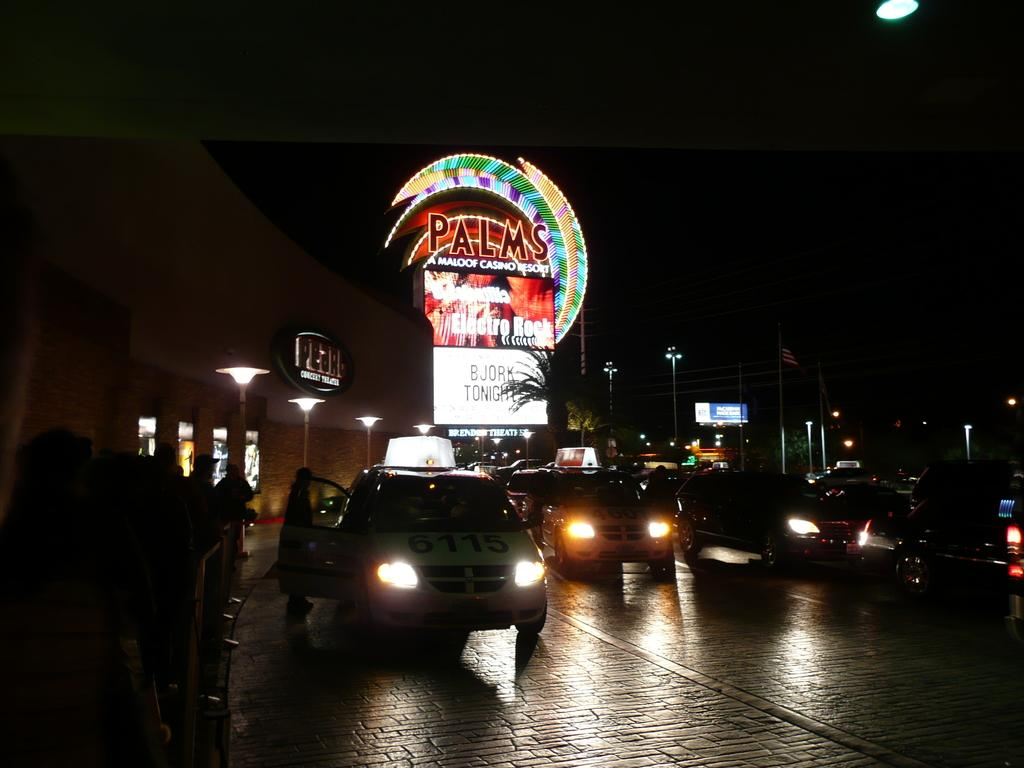<image>
Provide a brief description of the given image. Taxis waiting outside at night at Palms casino resort. 